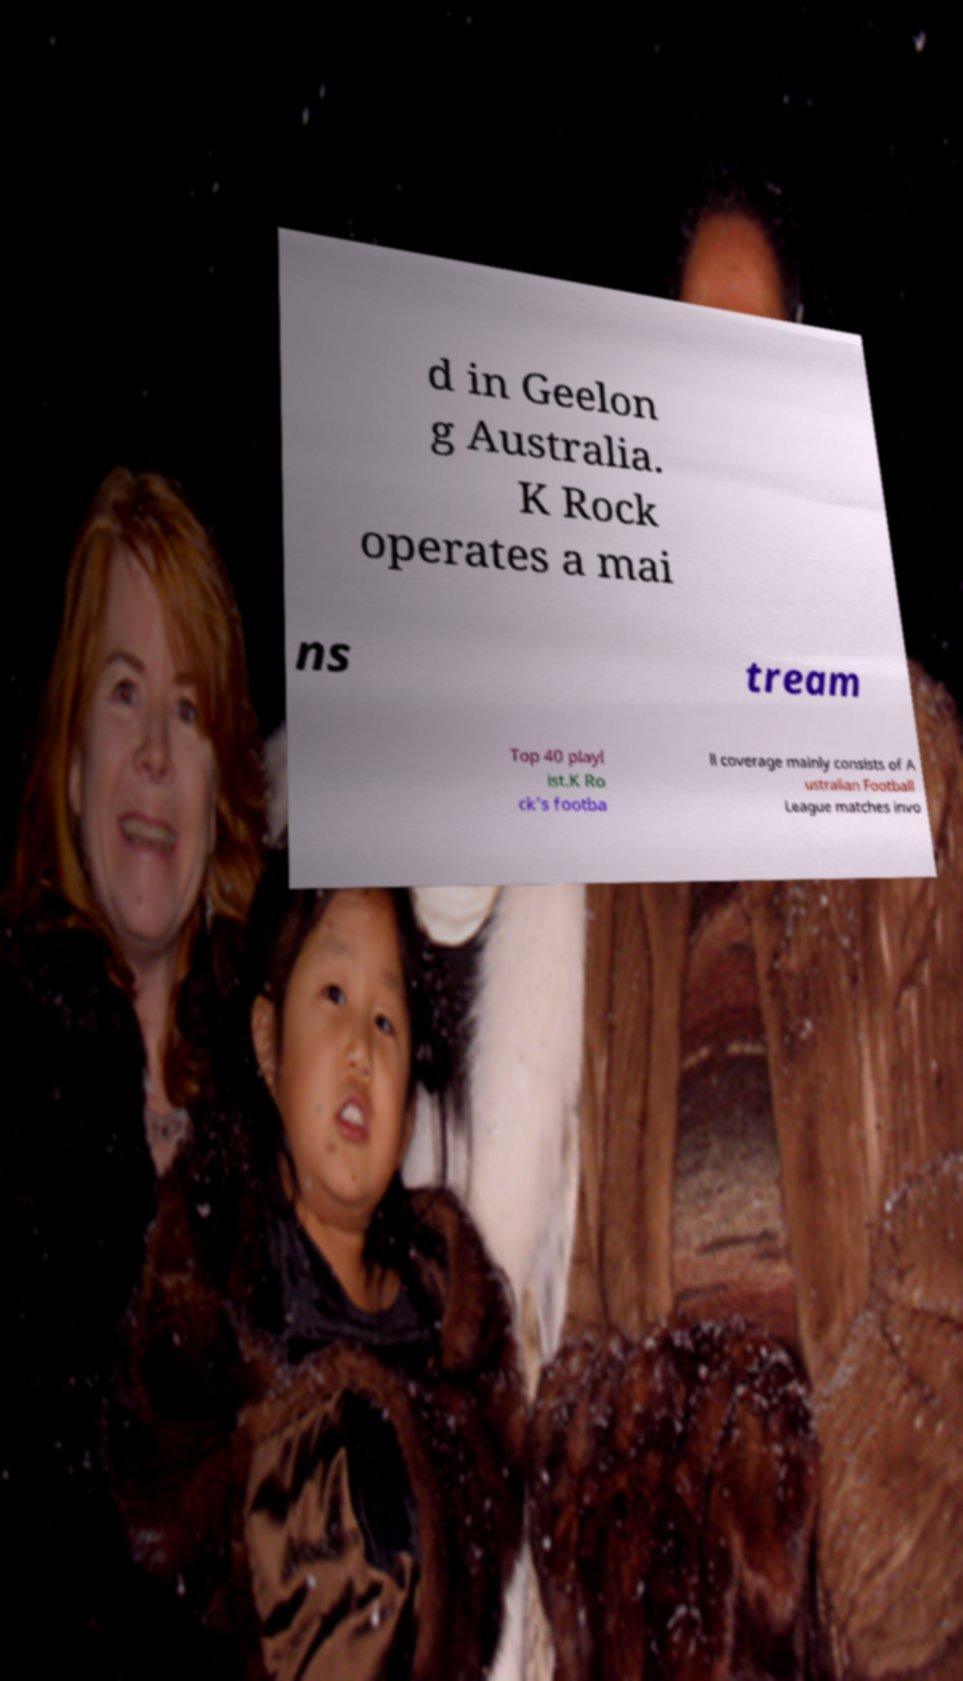What messages or text are displayed in this image? I need them in a readable, typed format. d in Geelon g Australia. K Rock operates a mai ns tream Top 40 playl ist.K Ro ck’s footba ll coverage mainly consists of A ustralian Football League matches invo 